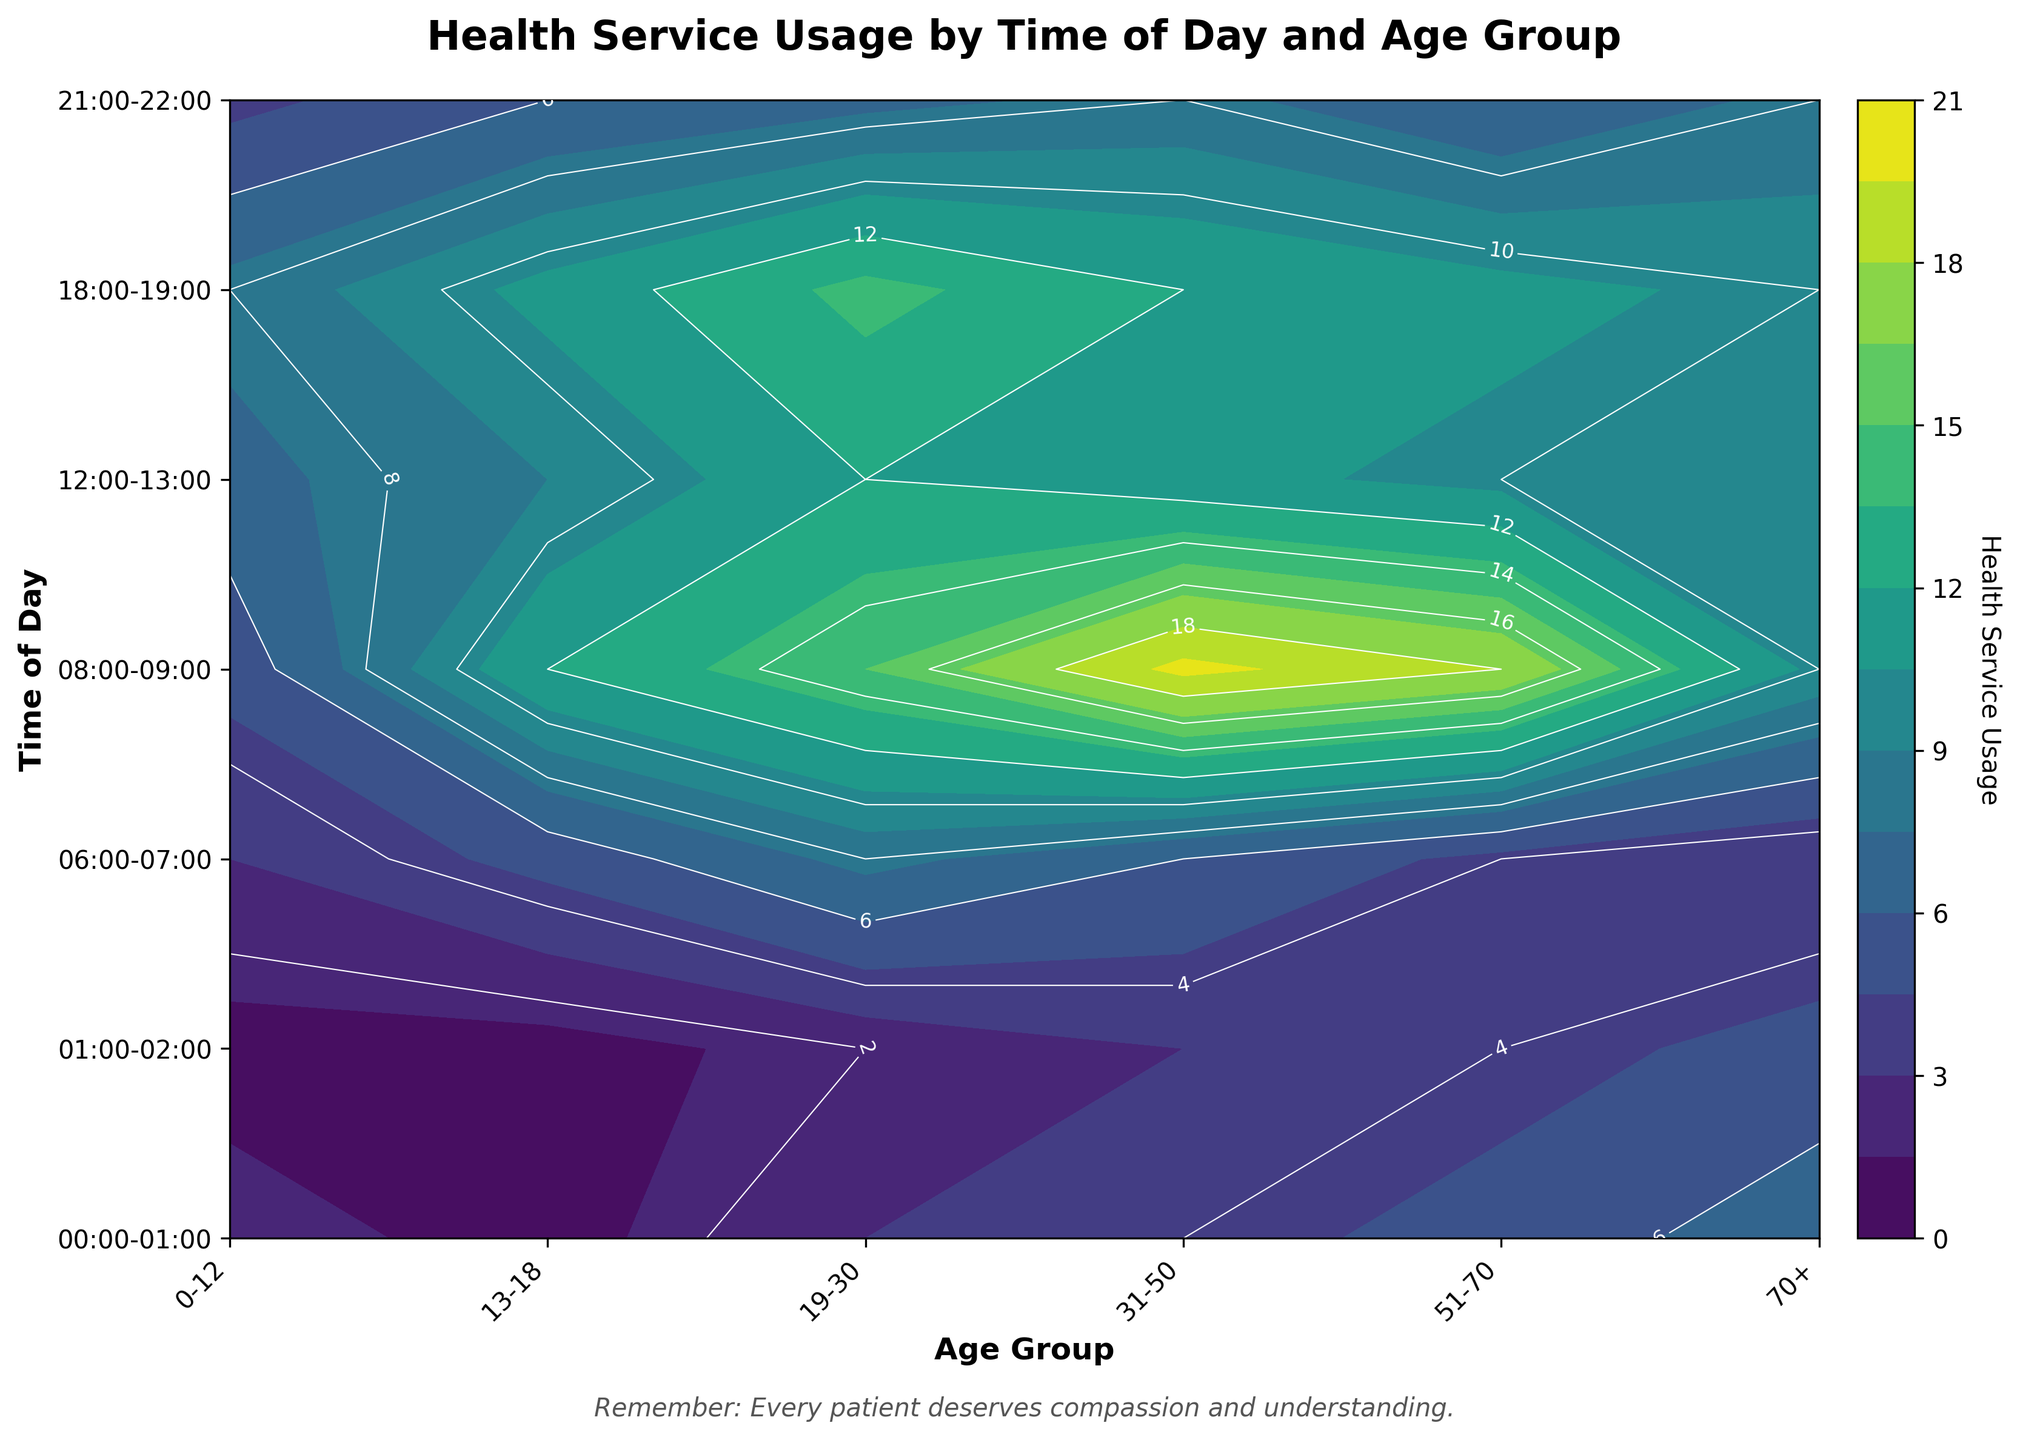What is the title of the plot? The title is usually located at the top of the plot and provides an overview of what the plot is about. Here, the title is "Health Service Usage by Time of Day and Age Group".
Answer: Health Service Usage by Time of Day and Age Group Which age group has the highest health service usage between 00:00-01:00? By looking at the contour labels for the time slot 00:00-01:00, we can see that the age group "70+" has the highest usage labeled as 7.
Answer: 70+ How many unique times of day are being considered in this plot? The y-axis lists the unique times of day. By counting them, we find there are 7 unique times of day.
Answer: 7 Which age group has the lowest usage in the time slot 06:00-07:00? By checking the contour labels for 06:00-07:00, the age group "70+" has the lowest usage of 3.
Answer: 70+ Compare the health service usage of 13-18 year olds between 08:00-09:00 and 18:00-19:00. Which time slot has higher usage? By observing the contour labels, health service usage at 08:00-09:00 is 12, and at 18:00-19:00 is 11 for age 13-18. Thus, it is higher at 08:00-09:00.
Answer: 08:00-09:00 What is the overall trend of health service usage for the age group 31-50? Observing the contour labels for age group 31-50 across all times, usage increases reaching a peak, then declines. Highest usage is seen at 08:00-09:00 with 20 units.
Answer: Increase and then decrease During what time of day does the age group 0-12 experience their peak health service usage? By scanning the contour plot labels for the age group "0-12", the highest usage of 8 is observed at 18:00-19:00.
Answer: 18:00-19:00 What is the average health service usage for the age group 51-70 across all times listed? Summing the usage for age group 51-70 (5, 4, 4, 18, 10, 11, 6) and dividing by 7: (5+4+4+18+10+11+6)/7 = 8.29.
Answer: 8.29 At 21:00-22:00, is the health service usage higher for age group 31-50 or for 51-70? Comparing the usage values at 21:00-22:00, both age group 31-50 and 51-70 have the same value of 6.
Answer: Equal 